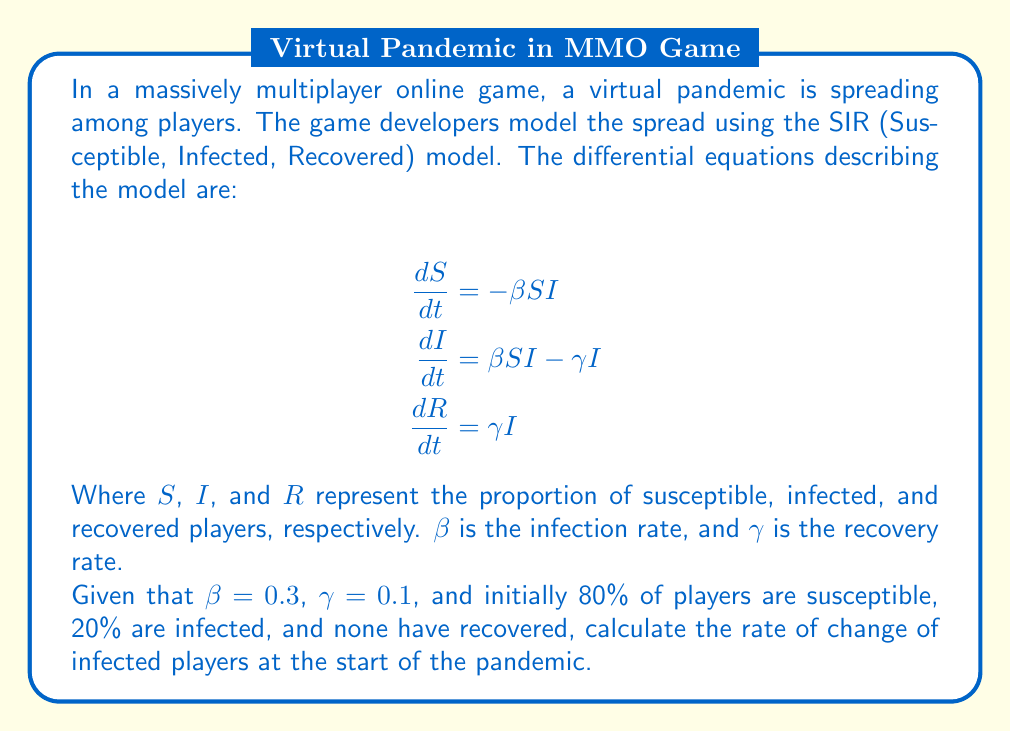Teach me how to tackle this problem. Let's approach this step-by-step:

1) First, we need to identify the initial conditions:
   $S(0) = 0.8$ (80% susceptible)
   $I(0) = 0.2$ (20% infected)
   $R(0) = 0$ (0% recovered)

2) We're interested in $\frac{dI}{dt}$ at $t=0$, which is given by:
   $$\frac{dI}{dt} = \beta SI - \gamma I$$

3) We're given that $\beta = 0.3$ and $\gamma = 0.1$

4) Now, let's substitute these values into the equation:
   $$\frac{dI}{dt} = (0.3)(0.8)(0.2) - (0.1)(0.2)$$

5) Let's calculate each term:
   $(0.3)(0.8)(0.2) = 0.048$
   $(0.1)(0.2) = 0.02$

6) Now we can subtract:
   $$\frac{dI}{dt} = 0.048 - 0.02 = 0.028$$

7) This means that at the start of the pandemic, the proportion of infected players is increasing at a rate of 0.028 per unit time.
Answer: $0.028$ 